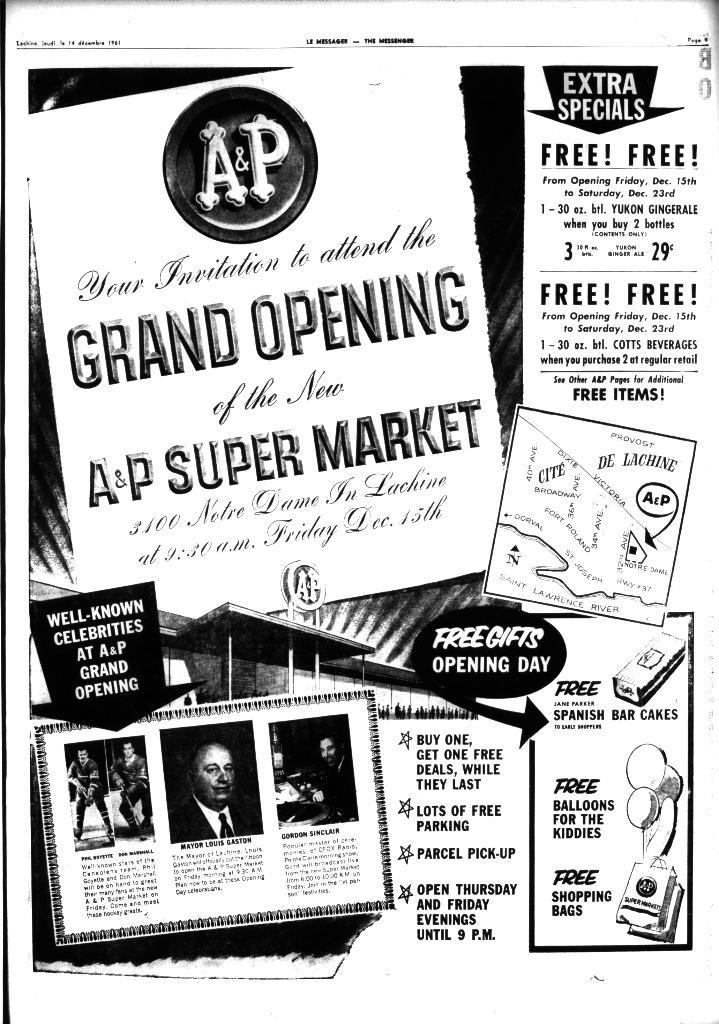What color scheme is used in the advertisement? The advertisement is black and white. What type of sweater is being advertised in the image? There is no sweater present in the image, as the advertisement is black and white. What health benefits are mentioned in the advertisement? There is no mention of health benefits in the advertisement, as it is black and white and does not contain any text or specific product information. 